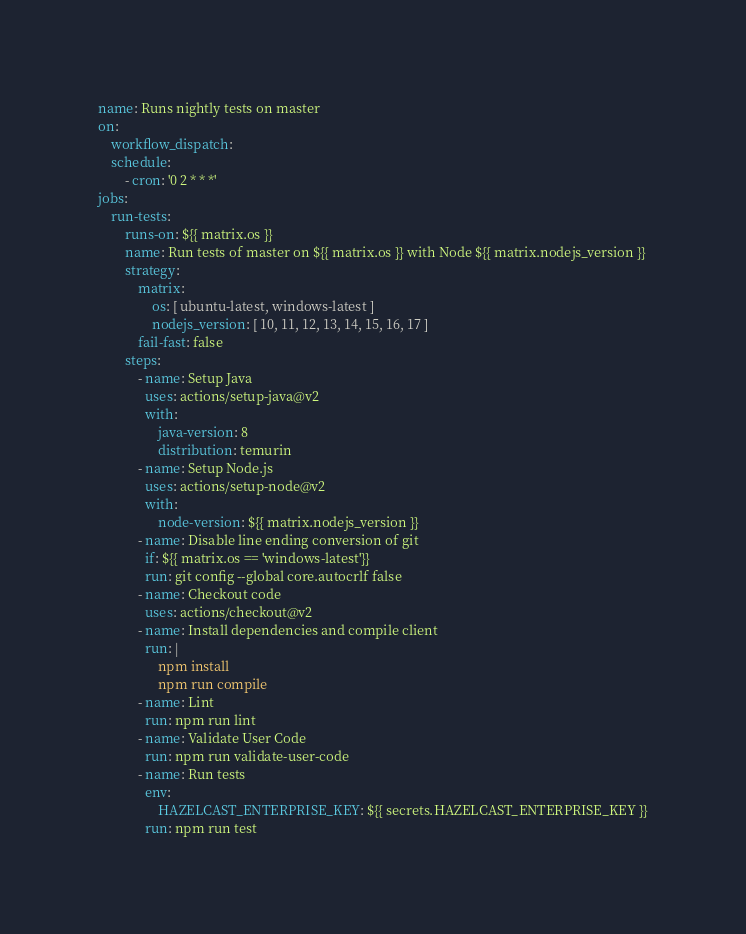Convert code to text. <code><loc_0><loc_0><loc_500><loc_500><_YAML_>name: Runs nightly tests on master
on:
    workflow_dispatch:
    schedule:
        - cron: '0 2 * * *'
jobs:
    run-tests:
        runs-on: ${{ matrix.os }}
        name: Run tests of master on ${{ matrix.os }} with Node ${{ matrix.nodejs_version }}
        strategy:
            matrix:
                os: [ ubuntu-latest, windows-latest ]
                nodejs_version: [ 10, 11, 12, 13, 14, 15, 16, 17 ]
            fail-fast: false
        steps:
            - name: Setup Java
              uses: actions/setup-java@v2
              with:
                  java-version: 8
                  distribution: temurin
            - name: Setup Node.js
              uses: actions/setup-node@v2
              with:
                  node-version: ${{ matrix.nodejs_version }}
            - name: Disable line ending conversion of git
              if: ${{ matrix.os == 'windows-latest'}}
              run: git config --global core.autocrlf false
            - name: Checkout code
              uses: actions/checkout@v2
            - name: Install dependencies and compile client
              run: |
                  npm install
                  npm run compile
            - name: Lint
              run: npm run lint
            - name: Validate User Code
              run: npm run validate-user-code
            - name: Run tests
              env:
                  HAZELCAST_ENTERPRISE_KEY: ${{ secrets.HAZELCAST_ENTERPRISE_KEY }}
              run: npm run test
</code> 